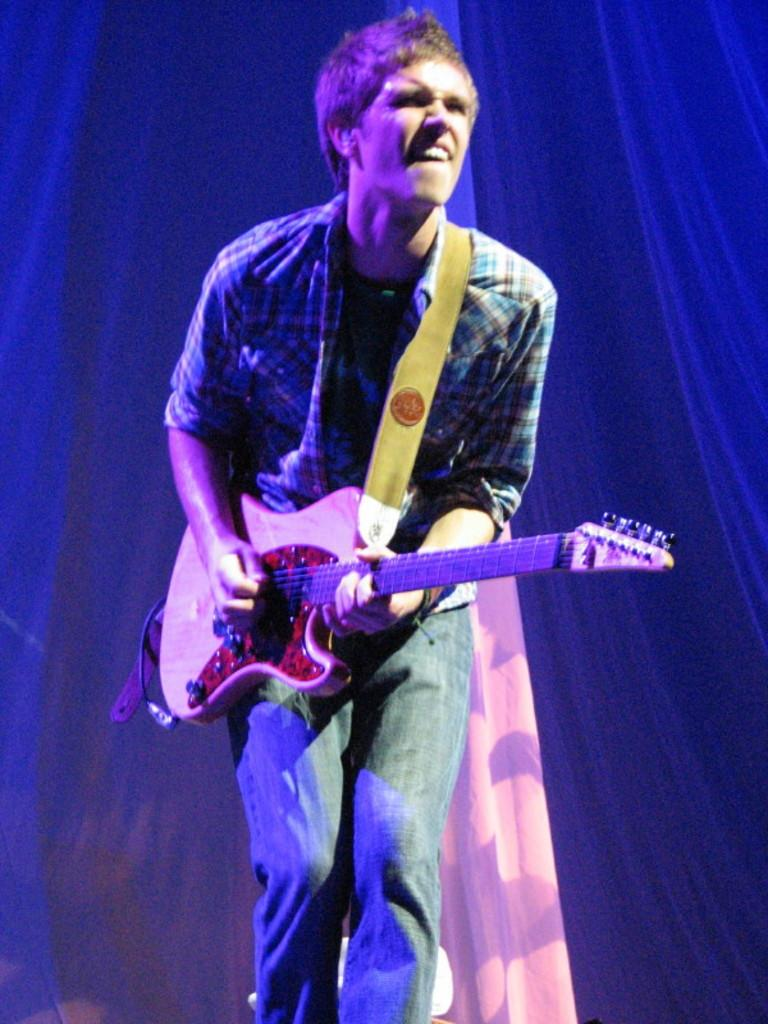What is the person in the image doing? The person is playing a guitar. What can be seen in the background of the image? There is a curtain in the background of the image. When was the image taken? The image was taken during nighttime. What type of produce is hanging from the branch in the image? There is no produce or branch present in the image. What color is the sky in the image? The color of the sky is not mentioned in the provided facts, as the image was taken during nighttime, and the sky is not visible. 